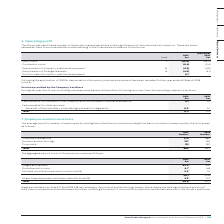According to Auto Trader's financial document, What was the total amount of fees payable in 2019? According to the financial document, 0.3 (in millions). The relevant text states: "Total 0.3 0.2..." Also, What do the fees payable for other services relate to? the audit of the subsidiary undertakings pursuant to legislation. The document states: "– the audit of the subsidiary undertakings pursuant to legislation 0.2 0.1..." Also, What do the fees in the table relate to? Services provided by the Company’s auditors. The document states: "Services provided by the Company’s auditors During the year, the Group (including overseas subsidiaries) obtained the following services from t..." Additionally, In which year was the total amount of fees payable larger? According to the financial document, 2019. The relevant text states: "2019 £m 2018 £m..." Also, can you calculate: What was the change in the total amount of fees payable in 2019 from 2018? Based on the calculation: 0.3-0.2, the result is 0.1 (in millions). This is based on the information: "Total 0.3 0.2 Total 0.3 0.2..." The key data points involved are: 0.2, 0.3. Also, can you calculate: What was the percentage change in the total amount of fees payable in 2019 from 2018? To answer this question, I need to perform calculations using the financial data. The calculation is: (0.3-0.2)/0.2, which equals 50 (percentage). This is based on the information: "Total 0.3 0.2 Total 0.3 0.2..." The key data points involved are: 0.2, 0.3. 